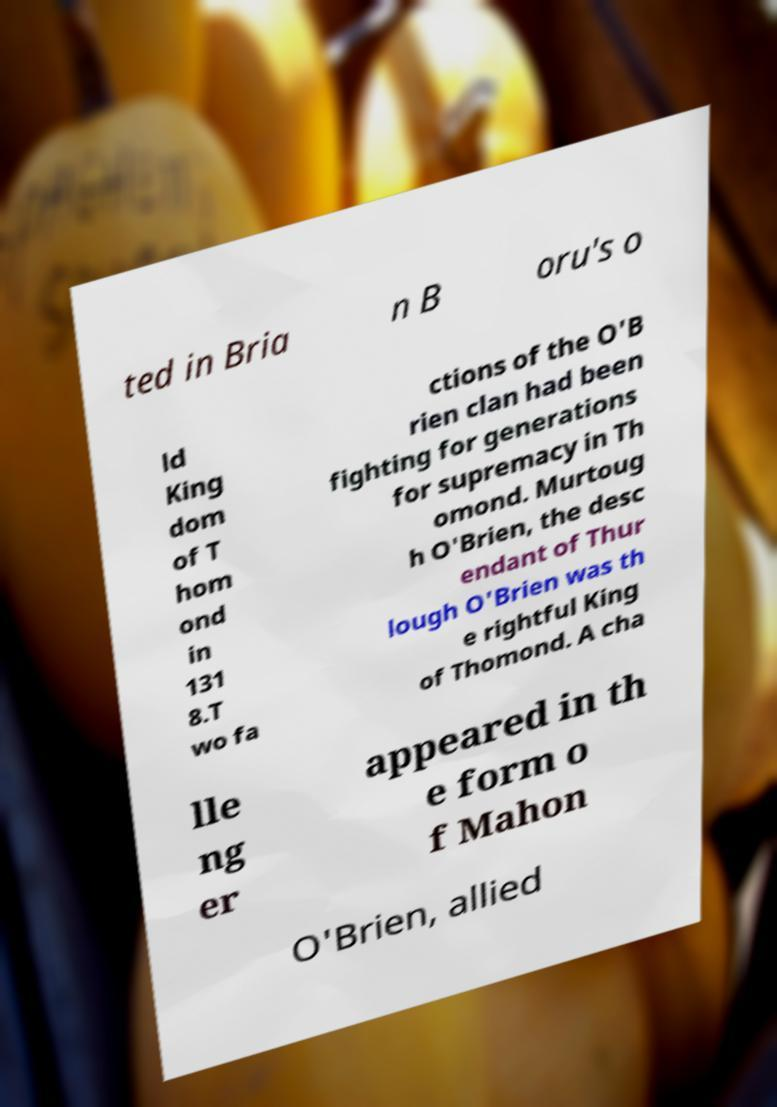Can you accurately transcribe the text from the provided image for me? ted in Bria n B oru's o ld King dom of T hom ond in 131 8.T wo fa ctions of the O'B rien clan had been fighting for generations for supremacy in Th omond. Murtoug h O'Brien, the desc endant of Thur lough O'Brien was th e rightful King of Thomond. A cha lle ng er appeared in th e form o f Mahon O'Brien, allied 